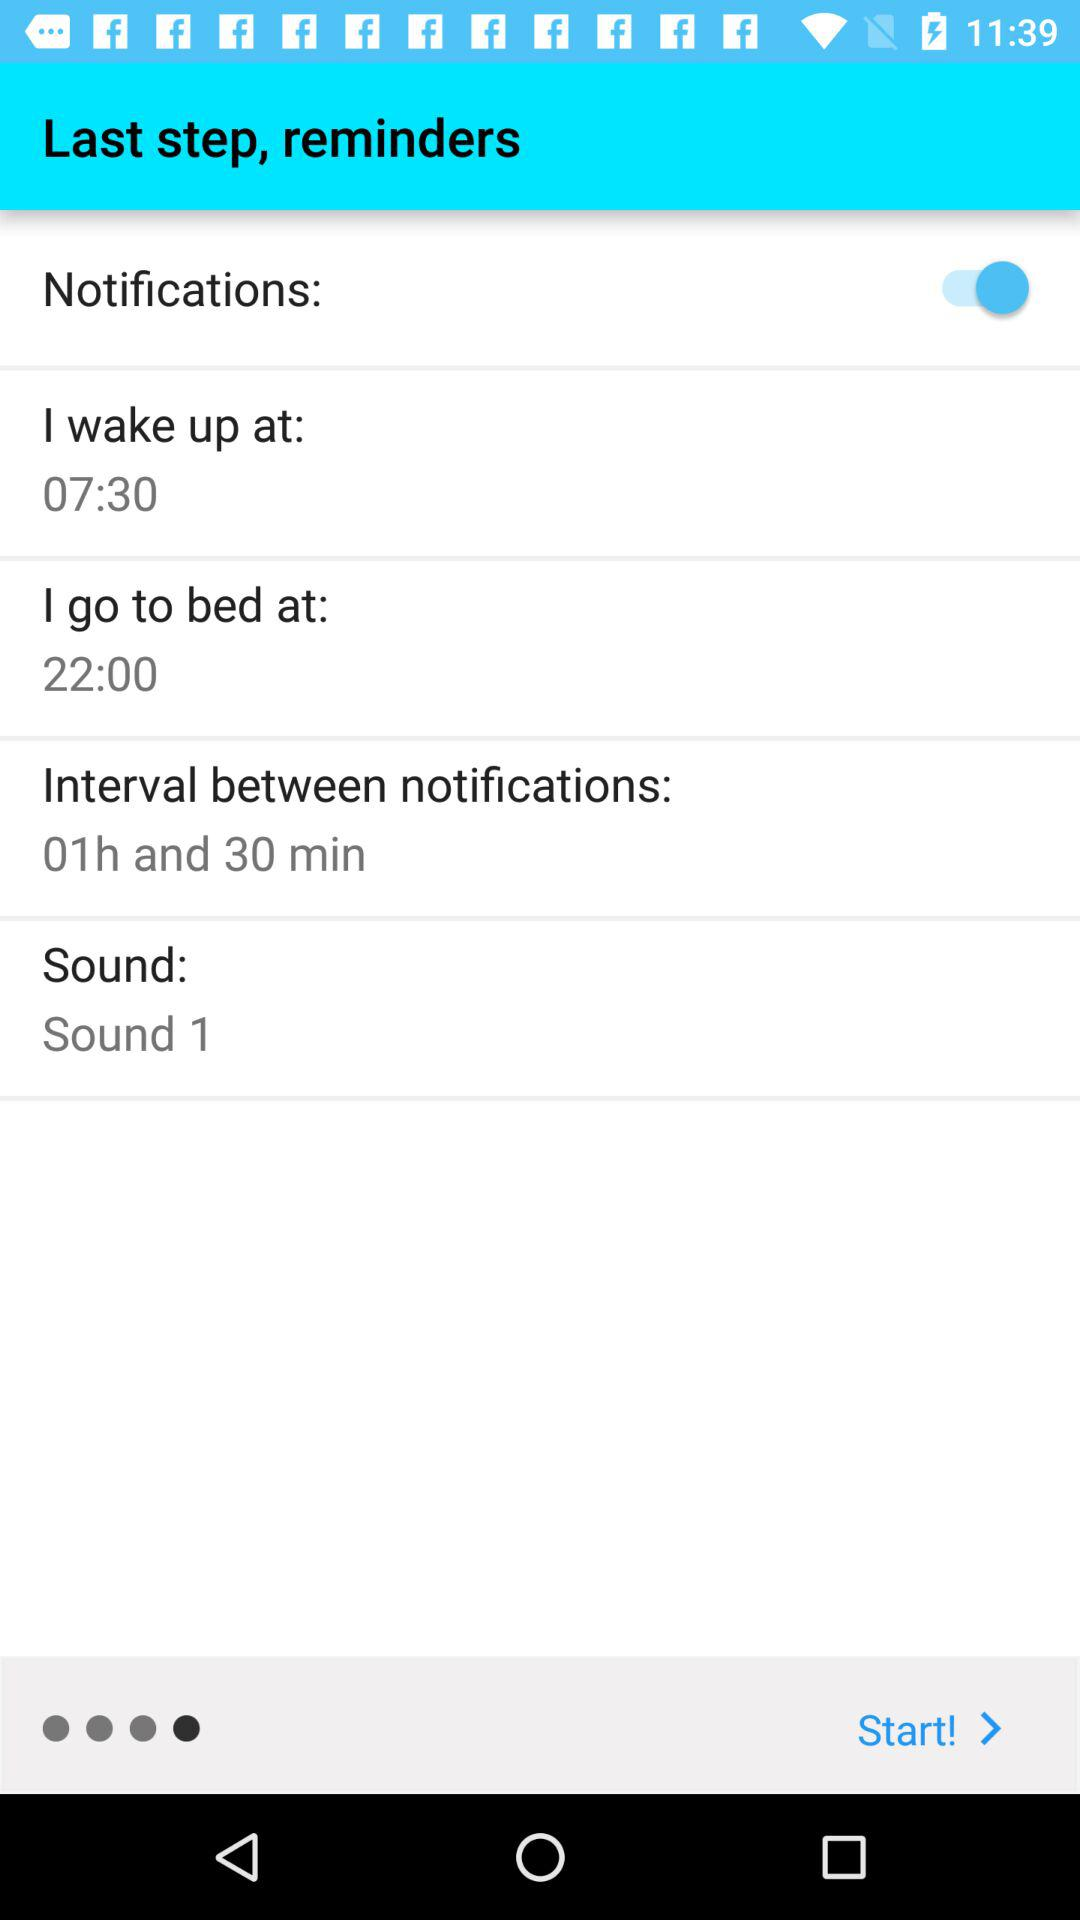What is the interval time between notifications? The interval time between notifications is 1 hour 30 minutes. 